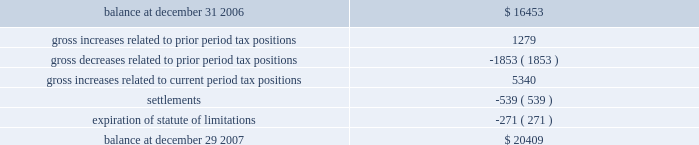Advance auto parts , inc .
And subsidiaries notes to the consolidated financial statements 2013 ( continued ) december 29 , 2007 , december 30 , 2006 and december 31 , 2005 ( in thousands , except per share data ) 11 .
Stock repurchase program : during fiscal 2007 , the company's board of directors authorized a new stock repurchase program of up to $ 500000 of the company's common stock plus related expenses .
The new program cancelled and replaced the remaining portion of the previous $ 300000 stock repurchase program .
The program allows the company to repurchase its common stock on the open market or in privately negotiated transactions from time to time in accordance with the requirements of the securities and exchange commission .
During fiscal 2007 , the company repurchased 8341 shares of common stock at an aggregate cost of $ 285869 , or an average price of $ 34.27 per share , of which 1330 shares of common stock were repurchased under the previous $ 300000 stock repurchase program .
As of december 29 , 2007 , 77 shares have been repurchased at an aggregate cost of $ 2959 and remained unsettled .
During fiscal 2007 , the company retired 6329 shares previously repurchased under the stock repurchase programs .
At december 29 , 2007 , the company had $ 260567 remaining under the current stock repurchase program .
Subsequent to december 29 , 2007 , the company repurchased 4563 shares of common stock at an aggregate cost of $ 155350 , or an average price of $ 34.04 per share .
During fiscal 2006 , the company retired 5117 shares of common stock which were previously repurchased under the company 2019s prior stock repurchase program .
These shares were repurchased during fiscal 2006 and fiscal 2005 at an aggregate cost of $ 192339 , or an average price of $ 37.59 per share .
12 .
Income taxes : as a result of the adoption of fin 48 on december 31 , 2006 , the company recorded an increase of $ 2275 to the liability for unrecognized tax benefits and a corresponding decrease in its balance of retained earnings .
The table summarizes the activity related to our unrecognized tax benefits for the fiscal year ended december 29 , 2007: .
As of december 29 , 2007 the entire amount of unrecognized tax benefits , if recognized , would reduce the company 2019s annual effective tax rate .
With the adoption of fin 48 , the company provides for interest and penalties as a part of income tax expense .
During fiscal 2007 , the company accrued potential penalties and interest of $ 709 and $ 1827 , respectively , related to these unrecognized tax benefits .
As of december 29 , 2007 , the company has recorded a liability for potential penalties and interest of $ 1843 and $ 4421 , respectively .
Prior to the adoption of fin 48 , the company classified interest associated with tax contingencies in interest expense .
The company has not provided for any penalties associated with tax contingencies unless considered probable of assessment .
The company does not expect its unrecognized tax benefits to change significantly over the next 12 months .
During the next 12 months , it is possible the company could conclude on $ 2000 to $ 3000 of the contingencies associated with unrecognized tax uncertainties due mainly to settlements and expiration of statute of limitations ( including tax benefits , interest and penalties ) .
The majority of these resolutions would be achieved through the completion of current income tax examinations. .
What is the percentage change in the stock price from average price of 2005 and 2006 to the average price of 2007? 
Computations: ((34.27 - 37.59) / 37.59)
Answer: -0.08832. 